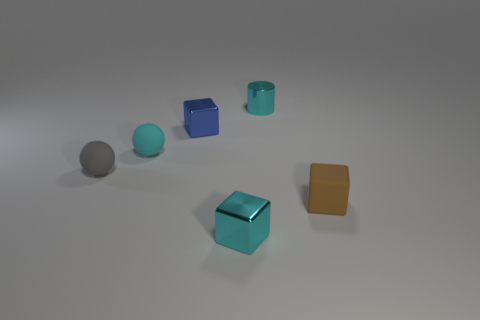There is a small matte thing that is right of the small cyan ball; what color is it?
Your response must be concise. Brown. What size is the blue object that is the same material as the cyan cylinder?
Offer a very short reply. Small. What number of small gray matte objects have the same shape as the blue shiny object?
Ensure brevity in your answer.  0. What is the material of the cyan sphere that is the same size as the brown rubber block?
Offer a terse response. Rubber. Is there a small green thing made of the same material as the small brown cube?
Your response must be concise. No. What is the color of the small rubber thing that is in front of the cyan sphere and left of the small cyan metal cylinder?
Ensure brevity in your answer.  Gray. What number of other things are there of the same color as the rubber cube?
Your answer should be compact. 0. There is a cube behind the block that is to the right of the tiny thing that is behind the blue thing; what is it made of?
Your answer should be compact. Metal. What number of blocks are tiny blue objects or brown objects?
Your answer should be compact. 2. Is there anything else that has the same size as the blue object?
Your response must be concise. Yes. 